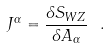Convert formula to latex. <formula><loc_0><loc_0><loc_500><loc_500>J ^ { \alpha } = \frac { \delta S _ { W Z } } { \delta A _ { \alpha } } \ .</formula> 